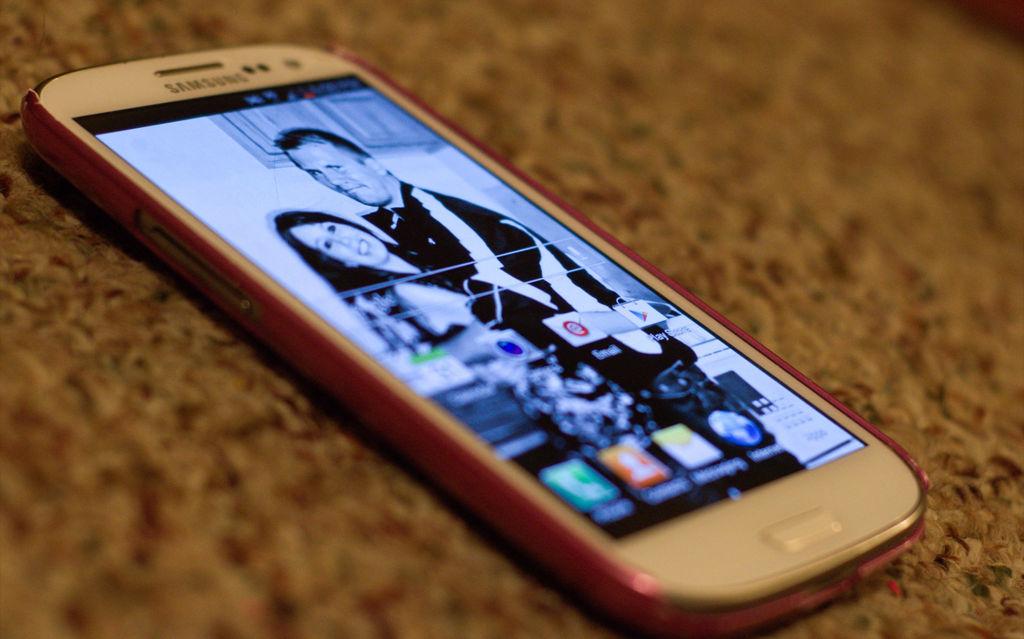What kind of cell phone is that?
Give a very brief answer. Samsung. What app is visible on the screen?
Provide a short and direct response. Email. 